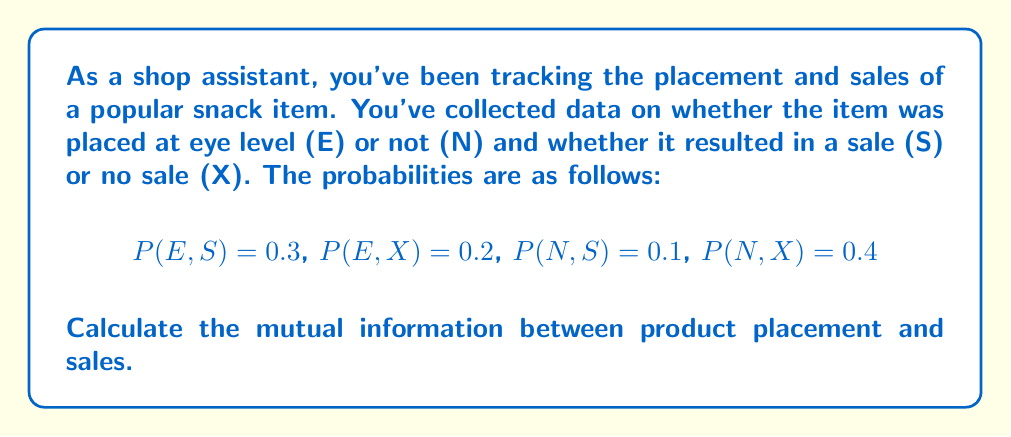Show me your answer to this math problem. To calculate the mutual information $I(X;Y)$ between product placement (X) and sales (Y), we'll follow these steps:

1) First, we need to calculate the marginal probabilities:
   $P(E) = P(E,S) + P(E,X) = 0.3 + 0.2 = 0.5$
   $P(N) = P(N,S) + P(N,X) = 0.1 + 0.4 = 0.5$
   $P(S) = P(E,S) + P(N,S) = 0.3 + 0.1 = 0.4$
   $P(X) = P(E,X) + P(N,X) = 0.2 + 0.4 = 0.6$

2) The formula for mutual information is:
   $$I(X;Y) = \sum_{x \in X} \sum_{y \in Y} P(x,y) \log_2 \frac{P(x,y)}{P(x)P(y)}$$

3) Let's calculate each term:
   For (E,S): $0.3 \log_2 \frac{0.3}{0.5 \cdot 0.4} = 0.3 \log_2 1.5 = 0.3 \cdot 0.5850 = 0.1755$
   For (E,X): $0.2 \log_2 \frac{0.2}{0.5 \cdot 0.6} = 0.2 \log_2 0.6667 = 0.2 \cdot (-0.5850) = -0.1170$
   For (N,S): $0.1 \log_2 \frac{0.1}{0.5 \cdot 0.4} = 0.1 \log_2 0.5 = 0.1 \cdot (-1) = -0.1$
   For (N,X): $0.4 \log_2 \frac{0.4}{0.5 \cdot 0.6} = 0.4 \log_2 1.3333 = 0.4 \cdot 0.4150 = 0.1660$

4) Sum all these terms:
   $I(X;Y) = 0.1755 + (-0.1170) + (-0.1) + 0.1660 = 0.1245$ bits
Answer: The mutual information between product placement and sales is 0.1245 bits. 